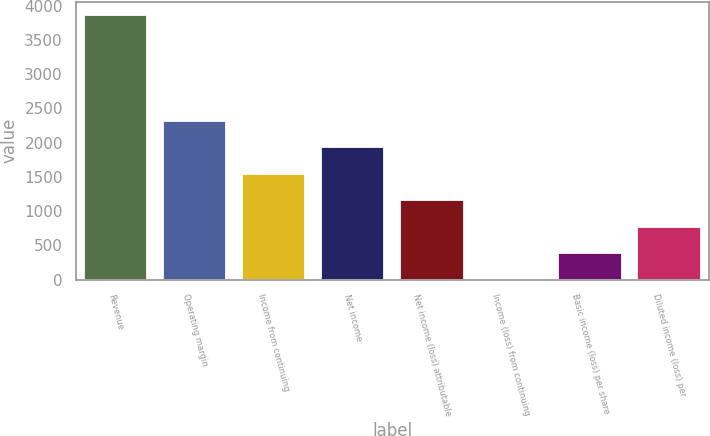<chart> <loc_0><loc_0><loc_500><loc_500><bar_chart><fcel>Revenue<fcel>Operating margin<fcel>Income from continuing<fcel>Net income<fcel>Net income (loss) attributable<fcel>Income (loss) from continuing<fcel>Basic income (loss) per share<fcel>Diluted income (loss) per<nl><fcel>3858<fcel>2314.84<fcel>1543.26<fcel>1929.05<fcel>1157.47<fcel>0.1<fcel>385.89<fcel>771.68<nl></chart> 